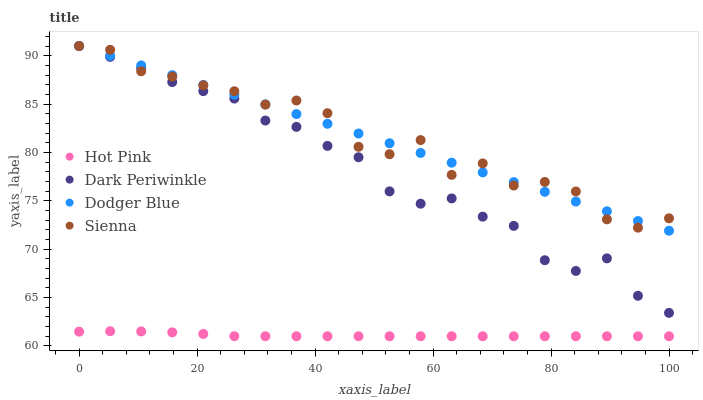Does Hot Pink have the minimum area under the curve?
Answer yes or no. Yes. Does Sienna have the maximum area under the curve?
Answer yes or no. Yes. Does Dodger Blue have the minimum area under the curve?
Answer yes or no. No. Does Dodger Blue have the maximum area under the curve?
Answer yes or no. No. Is Dodger Blue the smoothest?
Answer yes or no. Yes. Is Sienna the roughest?
Answer yes or no. Yes. Is Hot Pink the smoothest?
Answer yes or no. No. Is Hot Pink the roughest?
Answer yes or no. No. Does Hot Pink have the lowest value?
Answer yes or no. Yes. Does Dodger Blue have the lowest value?
Answer yes or no. No. Does Dark Periwinkle have the highest value?
Answer yes or no. Yes. Does Hot Pink have the highest value?
Answer yes or no. No. Is Hot Pink less than Sienna?
Answer yes or no. Yes. Is Dodger Blue greater than Hot Pink?
Answer yes or no. Yes. Does Dark Periwinkle intersect Dodger Blue?
Answer yes or no. Yes. Is Dark Periwinkle less than Dodger Blue?
Answer yes or no. No. Is Dark Periwinkle greater than Dodger Blue?
Answer yes or no. No. Does Hot Pink intersect Sienna?
Answer yes or no. No. 